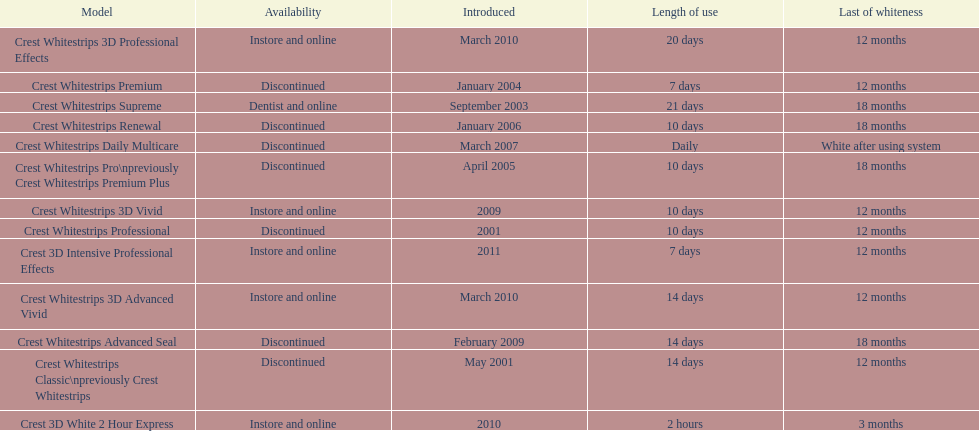Does the crest white strips classic last at least one year? Yes. 